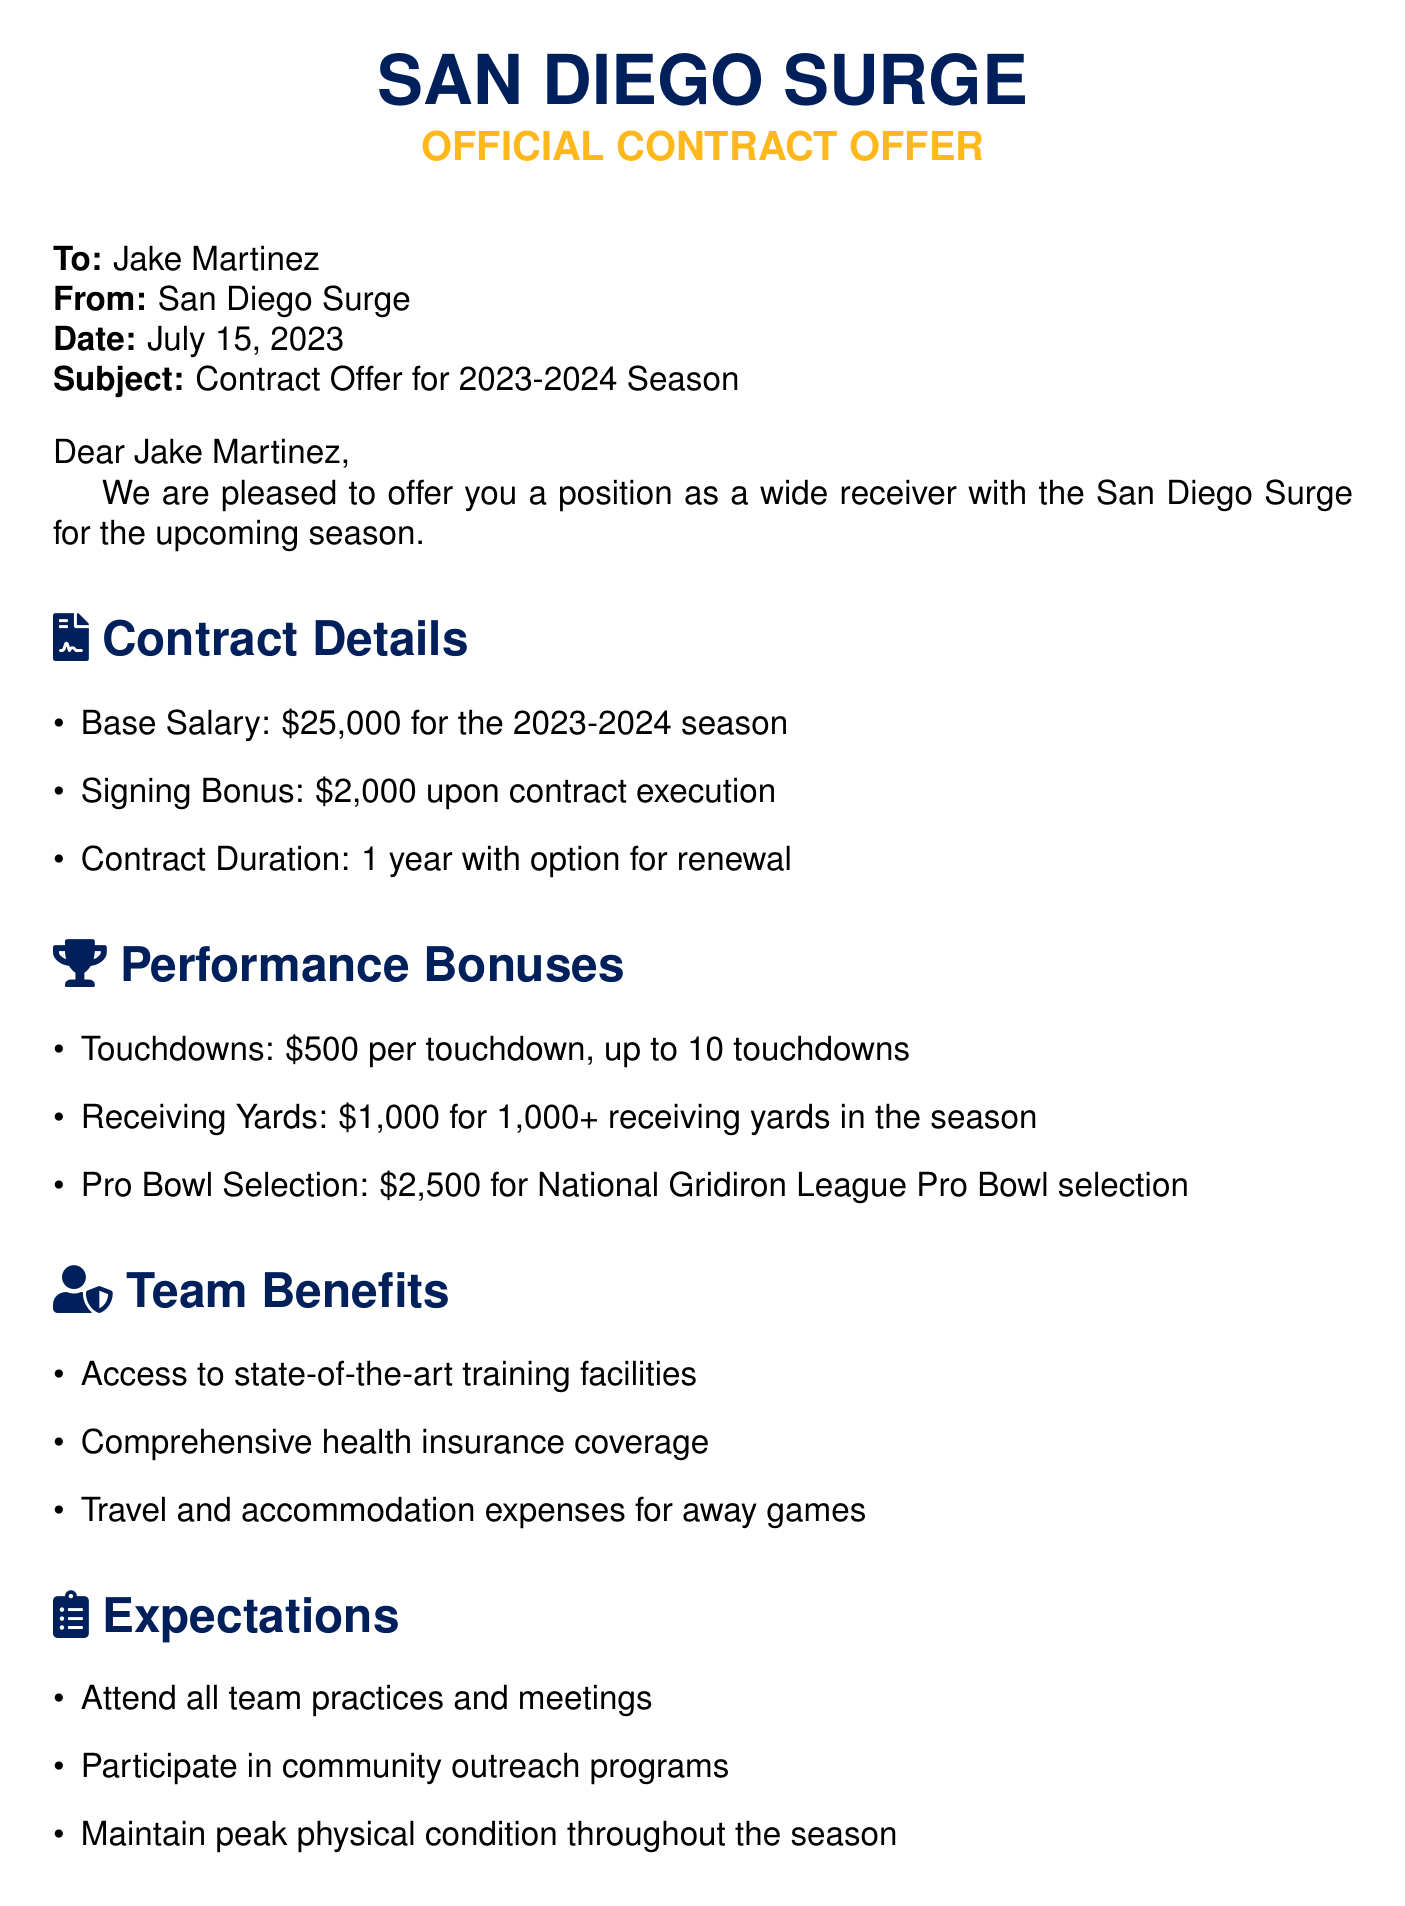what is the base salary for the 2023-2024 season? The base salary for the 2023-2024 season is clearly stated in the contract details section.
Answer: $25,000 what is the signing bonus? The signing bonus is mentioned in the contract details section.
Answer: $2,000 how long is the contract duration? The contract duration is specified in the contract details section.
Answer: 1 year how much can be earned per touchdown? The amount earned per touchdown is indicated in the performance bonuses section.
Answer: $500 what is the bonus for selecting the Pro Bowl? The bonus for Pro Bowl selection is detailed in the performance bonuses section.
Answer: $2,500 what are the expectations for the player? The expectations for the player are listed in the expectations section of the document.
Answer: Attend all team practices and meetings, participate in community outreach programs, maintain peak physical condition what type of insurance is provided? The type of insurance provided is mentioned in the team benefits section.
Answer: Comprehensive health insurance coverage how many touchdowns can be rewarded? The maximum number of touchdowns that can be rewarded is specified in the performance bonuses section.
Answer: 10 touchdowns who is the recipient of the contract offer? The recipient of the contract offer is mentioned at the top of the document.
Answer: Jake Martinez 